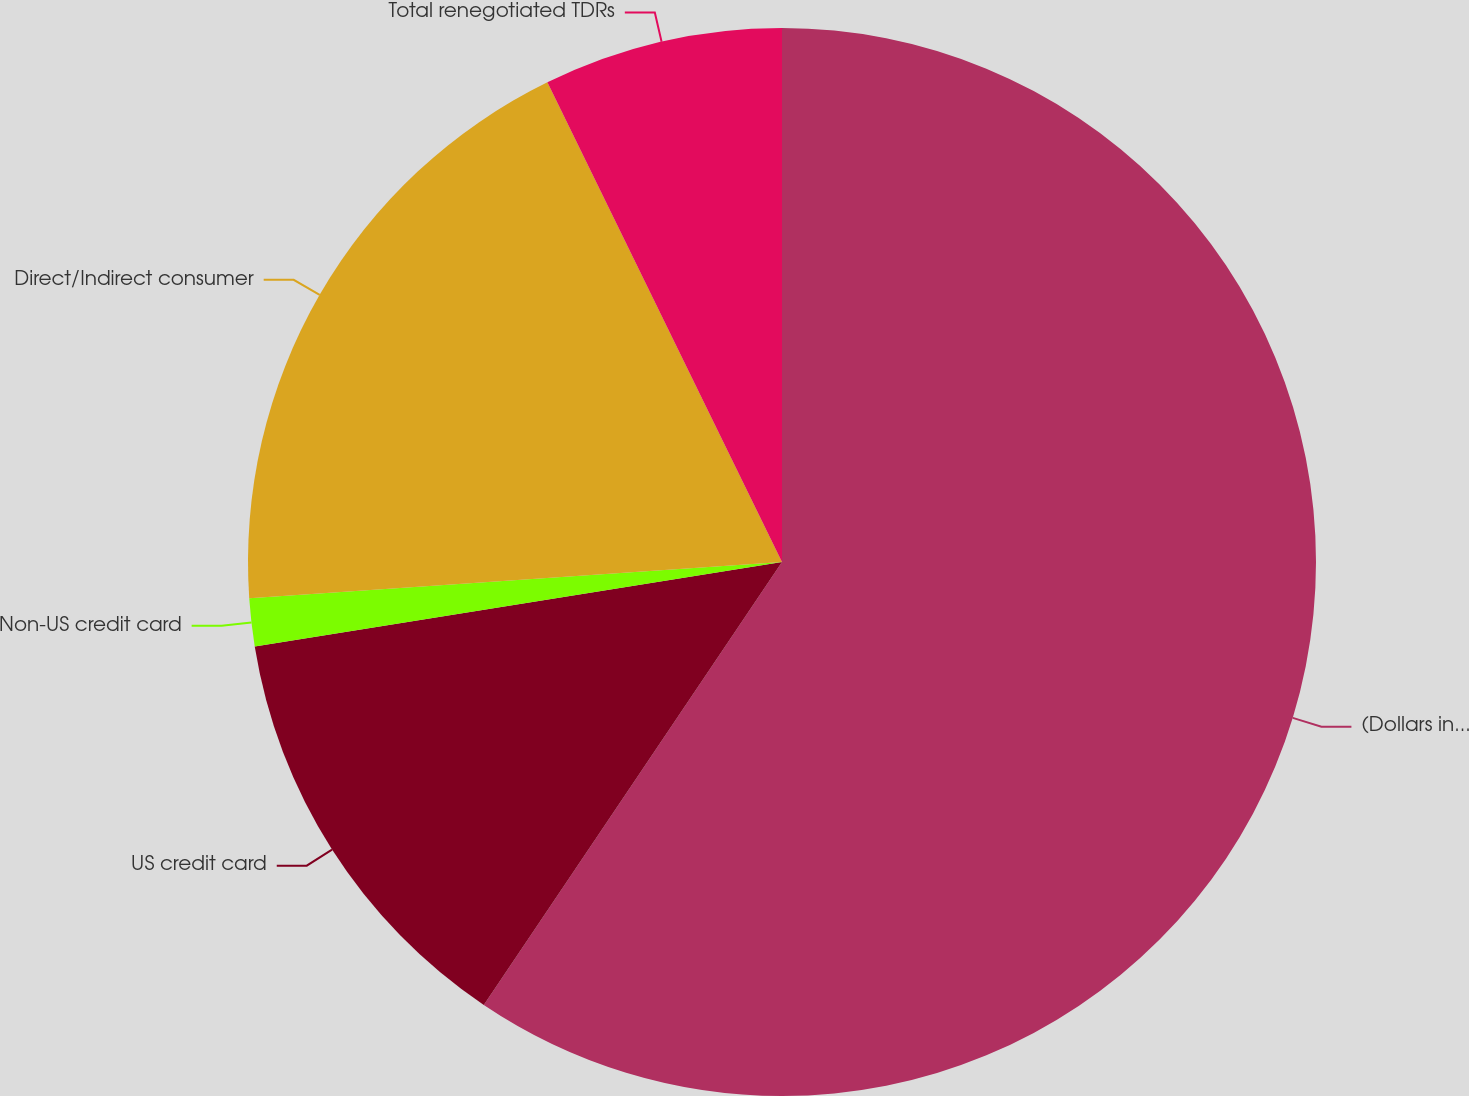Convert chart. <chart><loc_0><loc_0><loc_500><loc_500><pie_chart><fcel>(Dollars in millions)<fcel>US credit card<fcel>Non-US credit card<fcel>Direct/Indirect consumer<fcel>Total renegotiated TDRs<nl><fcel>59.43%<fcel>13.04%<fcel>1.45%<fcel>18.84%<fcel>7.24%<nl></chart> 